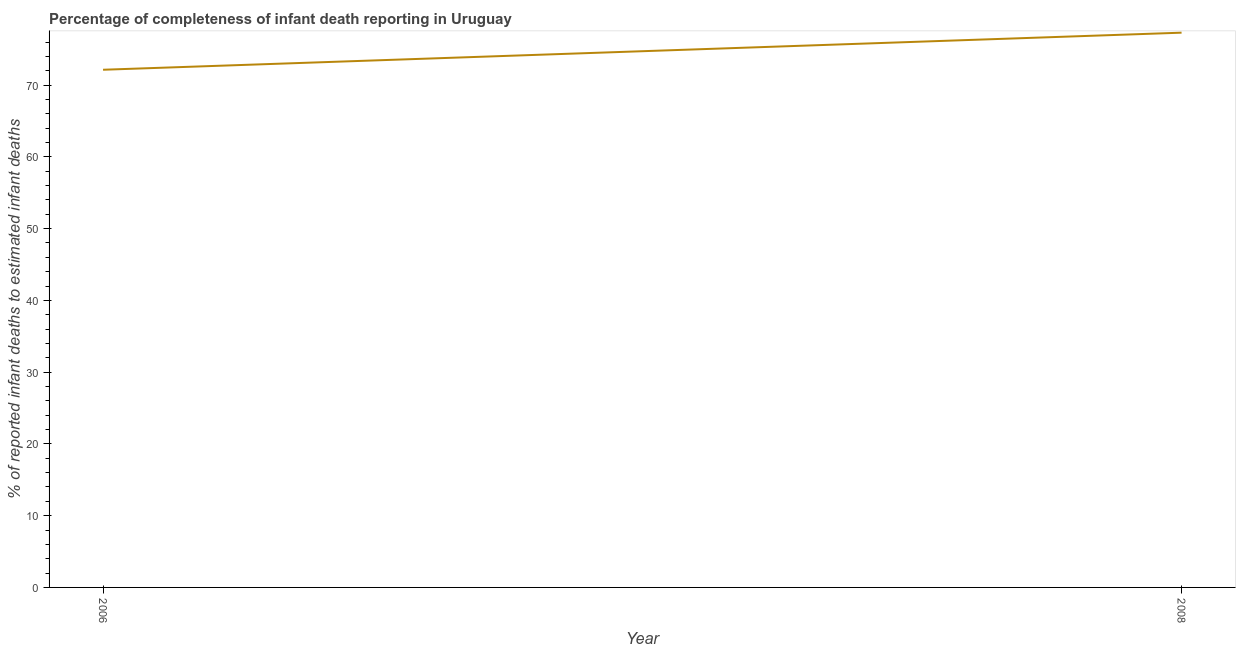What is the completeness of infant death reporting in 2008?
Provide a succinct answer. 77.3. Across all years, what is the maximum completeness of infant death reporting?
Your answer should be compact. 77.3. Across all years, what is the minimum completeness of infant death reporting?
Keep it short and to the point. 72.13. What is the sum of the completeness of infant death reporting?
Offer a terse response. 149.43. What is the difference between the completeness of infant death reporting in 2006 and 2008?
Your answer should be very brief. -5.17. What is the average completeness of infant death reporting per year?
Your answer should be very brief. 74.72. What is the median completeness of infant death reporting?
Offer a terse response. 74.72. In how many years, is the completeness of infant death reporting greater than 60 %?
Provide a succinct answer. 2. Do a majority of the years between 2006 and 2008 (inclusive) have completeness of infant death reporting greater than 62 %?
Your answer should be compact. Yes. What is the ratio of the completeness of infant death reporting in 2006 to that in 2008?
Your answer should be very brief. 0.93. In how many years, is the completeness of infant death reporting greater than the average completeness of infant death reporting taken over all years?
Offer a terse response. 1. Does the completeness of infant death reporting monotonically increase over the years?
Your answer should be very brief. Yes. How many years are there in the graph?
Give a very brief answer. 2. Does the graph contain any zero values?
Ensure brevity in your answer.  No. What is the title of the graph?
Ensure brevity in your answer.  Percentage of completeness of infant death reporting in Uruguay. What is the label or title of the Y-axis?
Keep it short and to the point. % of reported infant deaths to estimated infant deaths. What is the % of reported infant deaths to estimated infant deaths of 2006?
Keep it short and to the point. 72.13. What is the % of reported infant deaths to estimated infant deaths of 2008?
Make the answer very short. 77.3. What is the difference between the % of reported infant deaths to estimated infant deaths in 2006 and 2008?
Your response must be concise. -5.17. What is the ratio of the % of reported infant deaths to estimated infant deaths in 2006 to that in 2008?
Ensure brevity in your answer.  0.93. 